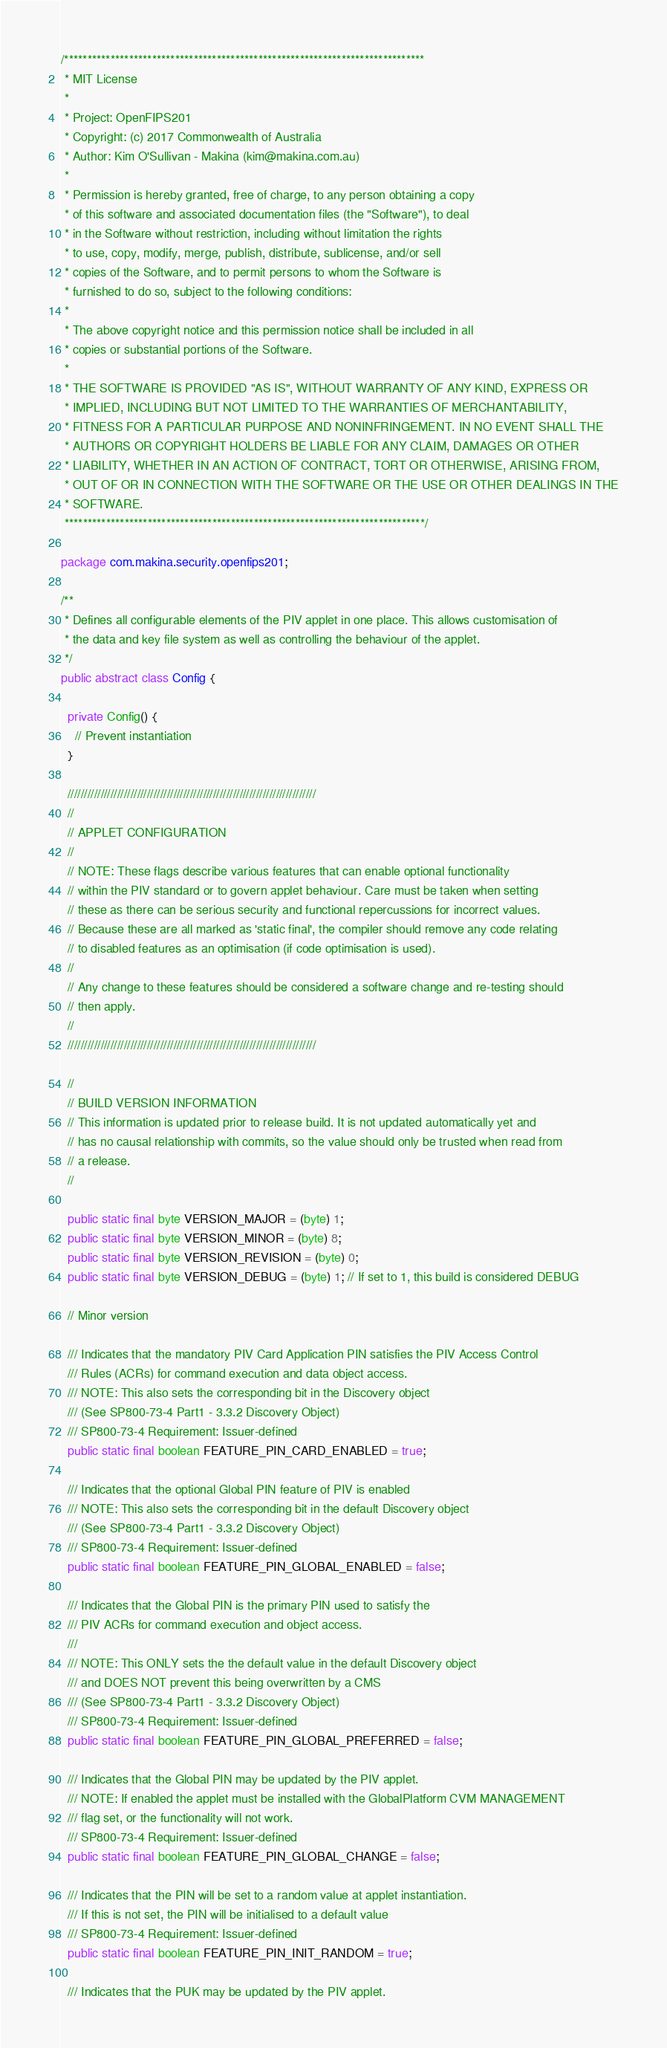Convert code to text. <code><loc_0><loc_0><loc_500><loc_500><_Java_>/******************************************************************************
 * MIT License
 *
 * Project: OpenFIPS201
 * Copyright: (c) 2017 Commonwealth of Australia
 * Author: Kim O'Sullivan - Makina (kim@makina.com.au)
 *
 * Permission is hereby granted, free of charge, to any person obtaining a copy
 * of this software and associated documentation files (the "Software"), to deal
 * in the Software without restriction, including without limitation the rights
 * to use, copy, modify, merge, publish, distribute, sublicense, and/or sell
 * copies of the Software, and to permit persons to whom the Software is
 * furnished to do so, subject to the following conditions:
 *
 * The above copyright notice and this permission notice shall be included in all
 * copies or substantial portions of the Software.
 *
 * THE SOFTWARE IS PROVIDED "AS IS", WITHOUT WARRANTY OF ANY KIND, EXPRESS OR
 * IMPLIED, INCLUDING BUT NOT LIMITED TO THE WARRANTIES OF MERCHANTABILITY,
 * FITNESS FOR A PARTICULAR PURPOSE AND NONINFRINGEMENT. IN NO EVENT SHALL THE
 * AUTHORS OR COPYRIGHT HOLDERS BE LIABLE FOR ANY CLAIM, DAMAGES OR OTHER
 * LIABILITY, WHETHER IN AN ACTION OF CONTRACT, TORT OR OTHERWISE, ARISING FROM,
 * OUT OF OR IN CONNECTION WITH THE SOFTWARE OR THE USE OR OTHER DEALINGS IN THE
 * SOFTWARE.
 ******************************************************************************/

package com.makina.security.openfips201;

/**
 * Defines all configurable elements of the PIV applet in one place. This allows customisation of
 * the data and key file system as well as controlling the behaviour of the applet.
 */
public abstract class Config {

  private Config() {
    // Prevent instantiation
  }

  ///////////////////////////////////////////////////////////////////////////
  //
  // APPLET CONFIGURATION
  //
  // NOTE: These flags describe various features that can enable optional functionality
  // within the PIV standard or to govern applet behaviour. Care must be taken when setting
  // these as there can be serious security and functional repercussions for incorrect values.
  // Because these are all marked as 'static final', the compiler should remove any code relating
  // to disabled features as an optimisation (if code optimisation is used).
  //
  // Any change to these features should be considered a software change and re-testing should
  // then apply.
  //
  ///////////////////////////////////////////////////////////////////////////

  //
  // BUILD VERSION INFORMATION
  // This information is updated prior to release build. It is not updated automatically yet and
  // has no causal relationship with commits, so the value should only be trusted when read from
  // a release.
  //

  public static final byte VERSION_MAJOR = (byte) 1;
  public static final byte VERSION_MINOR = (byte) 8;
  public static final byte VERSION_REVISION = (byte) 0;
  public static final byte VERSION_DEBUG = (byte) 1; // If set to 1, this build is considered DEBUG

  // Minor version

  /// Indicates that the mandatory PIV Card Application PIN satisfies the PIV Access Control
  /// Rules (ACRs) for command execution and data object access.
  /// NOTE: This also sets the corresponding bit in the Discovery object
  /// (See SP800-73-4 Part1 - 3.3.2 Discovery Object)
  /// SP800-73-4 Requirement: Issuer-defined
  public static final boolean FEATURE_PIN_CARD_ENABLED = true;

  /// Indicates that the optional Global PIN feature of PIV is enabled
  /// NOTE: This also sets the corresponding bit in the default Discovery object
  /// (See SP800-73-4 Part1 - 3.3.2 Discovery Object)
  /// SP800-73-4 Requirement: Issuer-defined
  public static final boolean FEATURE_PIN_GLOBAL_ENABLED = false;

  /// Indicates that the Global PIN is the primary PIN used to satisfy the
  /// PIV ACRs for command execution and object access.
  ///
  /// NOTE: This ONLY sets the the default value in the default Discovery object
  /// and DOES NOT prevent this being overwritten by a CMS
  /// (See SP800-73-4 Part1 - 3.3.2 Discovery Object)
  /// SP800-73-4 Requirement: Issuer-defined
  public static final boolean FEATURE_PIN_GLOBAL_PREFERRED = false;

  /// Indicates that the Global PIN may be updated by the PIV applet.
  /// NOTE: If enabled the applet must be installed with the GlobalPlatform CVM MANAGEMENT
  /// flag set, or the functionality will not work.
  /// SP800-73-4 Requirement: Issuer-defined
  public static final boolean FEATURE_PIN_GLOBAL_CHANGE = false;

  /// Indicates that the PIN will be set to a random value at applet instantiation.
  /// If this is not set, the PIN will be initialised to a default value
  /// SP800-73-4 Requirement: Issuer-defined
  public static final boolean FEATURE_PIN_INIT_RANDOM = true;

  /// Indicates that the PUK may be updated by the PIV applet.</code> 